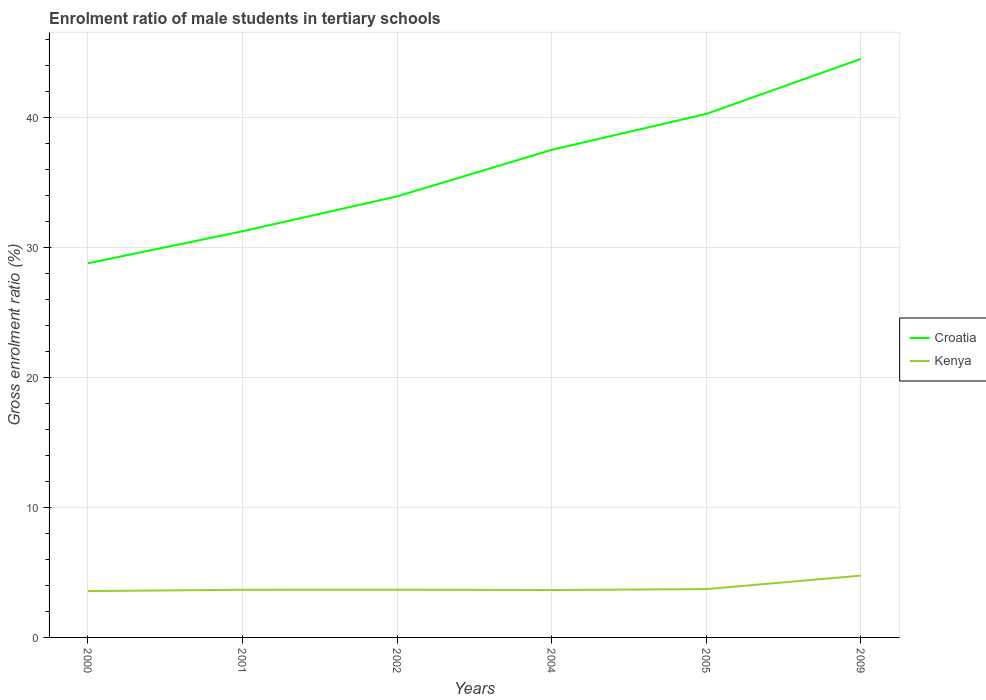Does the line corresponding to Croatia intersect with the line corresponding to Kenya?
Ensure brevity in your answer.  No. Is the number of lines equal to the number of legend labels?
Your response must be concise. Yes. Across all years, what is the maximum enrolment ratio of male students in tertiary schools in Kenya?
Provide a short and direct response. 3.56. In which year was the enrolment ratio of male students in tertiary schools in Kenya maximum?
Make the answer very short. 2000. What is the total enrolment ratio of male students in tertiary schools in Kenya in the graph?
Provide a short and direct response. -0.01. What is the difference between the highest and the second highest enrolment ratio of male students in tertiary schools in Kenya?
Ensure brevity in your answer.  1.19. What is the difference between the highest and the lowest enrolment ratio of male students in tertiary schools in Croatia?
Your answer should be very brief. 3. How many lines are there?
Offer a terse response. 2. How many years are there in the graph?
Keep it short and to the point. 6. Does the graph contain any zero values?
Provide a short and direct response. No. How are the legend labels stacked?
Make the answer very short. Vertical. What is the title of the graph?
Provide a short and direct response. Enrolment ratio of male students in tertiary schools. What is the label or title of the X-axis?
Keep it short and to the point. Years. What is the Gross enrolment ratio (%) in Croatia in 2000?
Offer a very short reply. 28.77. What is the Gross enrolment ratio (%) of Kenya in 2000?
Offer a terse response. 3.56. What is the Gross enrolment ratio (%) in Croatia in 2001?
Your answer should be very brief. 31.23. What is the Gross enrolment ratio (%) in Kenya in 2001?
Ensure brevity in your answer.  3.66. What is the Gross enrolment ratio (%) in Croatia in 2002?
Your answer should be compact. 33.92. What is the Gross enrolment ratio (%) of Kenya in 2002?
Offer a very short reply. 3.67. What is the Gross enrolment ratio (%) in Croatia in 2004?
Your answer should be very brief. 37.49. What is the Gross enrolment ratio (%) of Kenya in 2004?
Provide a short and direct response. 3.65. What is the Gross enrolment ratio (%) of Croatia in 2005?
Your answer should be compact. 40.26. What is the Gross enrolment ratio (%) of Kenya in 2005?
Keep it short and to the point. 3.72. What is the Gross enrolment ratio (%) of Croatia in 2009?
Your answer should be very brief. 44.49. What is the Gross enrolment ratio (%) of Kenya in 2009?
Offer a terse response. 4.75. Across all years, what is the maximum Gross enrolment ratio (%) of Croatia?
Make the answer very short. 44.49. Across all years, what is the maximum Gross enrolment ratio (%) of Kenya?
Ensure brevity in your answer.  4.75. Across all years, what is the minimum Gross enrolment ratio (%) in Croatia?
Keep it short and to the point. 28.77. Across all years, what is the minimum Gross enrolment ratio (%) in Kenya?
Keep it short and to the point. 3.56. What is the total Gross enrolment ratio (%) in Croatia in the graph?
Give a very brief answer. 216.16. What is the total Gross enrolment ratio (%) of Kenya in the graph?
Make the answer very short. 23.01. What is the difference between the Gross enrolment ratio (%) in Croatia in 2000 and that in 2001?
Ensure brevity in your answer.  -2.46. What is the difference between the Gross enrolment ratio (%) of Kenya in 2000 and that in 2001?
Your answer should be compact. -0.1. What is the difference between the Gross enrolment ratio (%) in Croatia in 2000 and that in 2002?
Your answer should be very brief. -5.15. What is the difference between the Gross enrolment ratio (%) of Kenya in 2000 and that in 2002?
Make the answer very short. -0.11. What is the difference between the Gross enrolment ratio (%) in Croatia in 2000 and that in 2004?
Give a very brief answer. -8.73. What is the difference between the Gross enrolment ratio (%) in Kenya in 2000 and that in 2004?
Your answer should be compact. -0.08. What is the difference between the Gross enrolment ratio (%) in Croatia in 2000 and that in 2005?
Your answer should be very brief. -11.49. What is the difference between the Gross enrolment ratio (%) of Kenya in 2000 and that in 2005?
Your answer should be compact. -0.15. What is the difference between the Gross enrolment ratio (%) of Croatia in 2000 and that in 2009?
Your answer should be compact. -15.72. What is the difference between the Gross enrolment ratio (%) of Kenya in 2000 and that in 2009?
Ensure brevity in your answer.  -1.19. What is the difference between the Gross enrolment ratio (%) in Croatia in 2001 and that in 2002?
Make the answer very short. -2.69. What is the difference between the Gross enrolment ratio (%) of Kenya in 2001 and that in 2002?
Ensure brevity in your answer.  -0.01. What is the difference between the Gross enrolment ratio (%) of Croatia in 2001 and that in 2004?
Offer a very short reply. -6.26. What is the difference between the Gross enrolment ratio (%) in Kenya in 2001 and that in 2004?
Make the answer very short. 0.02. What is the difference between the Gross enrolment ratio (%) of Croatia in 2001 and that in 2005?
Provide a short and direct response. -9.03. What is the difference between the Gross enrolment ratio (%) of Kenya in 2001 and that in 2005?
Your answer should be very brief. -0.05. What is the difference between the Gross enrolment ratio (%) in Croatia in 2001 and that in 2009?
Give a very brief answer. -13.26. What is the difference between the Gross enrolment ratio (%) of Kenya in 2001 and that in 2009?
Give a very brief answer. -1.09. What is the difference between the Gross enrolment ratio (%) in Croatia in 2002 and that in 2004?
Offer a very short reply. -3.58. What is the difference between the Gross enrolment ratio (%) of Kenya in 2002 and that in 2004?
Your answer should be compact. 0.03. What is the difference between the Gross enrolment ratio (%) of Croatia in 2002 and that in 2005?
Ensure brevity in your answer.  -6.34. What is the difference between the Gross enrolment ratio (%) in Kenya in 2002 and that in 2005?
Make the answer very short. -0.04. What is the difference between the Gross enrolment ratio (%) of Croatia in 2002 and that in 2009?
Provide a short and direct response. -10.57. What is the difference between the Gross enrolment ratio (%) of Kenya in 2002 and that in 2009?
Ensure brevity in your answer.  -1.08. What is the difference between the Gross enrolment ratio (%) of Croatia in 2004 and that in 2005?
Keep it short and to the point. -2.77. What is the difference between the Gross enrolment ratio (%) of Kenya in 2004 and that in 2005?
Your answer should be compact. -0.07. What is the difference between the Gross enrolment ratio (%) of Croatia in 2004 and that in 2009?
Your answer should be compact. -7. What is the difference between the Gross enrolment ratio (%) in Kenya in 2004 and that in 2009?
Provide a short and direct response. -1.11. What is the difference between the Gross enrolment ratio (%) in Croatia in 2005 and that in 2009?
Offer a very short reply. -4.23. What is the difference between the Gross enrolment ratio (%) of Kenya in 2005 and that in 2009?
Keep it short and to the point. -1.04. What is the difference between the Gross enrolment ratio (%) of Croatia in 2000 and the Gross enrolment ratio (%) of Kenya in 2001?
Your answer should be very brief. 25.1. What is the difference between the Gross enrolment ratio (%) in Croatia in 2000 and the Gross enrolment ratio (%) in Kenya in 2002?
Ensure brevity in your answer.  25.1. What is the difference between the Gross enrolment ratio (%) in Croatia in 2000 and the Gross enrolment ratio (%) in Kenya in 2004?
Keep it short and to the point. 25.12. What is the difference between the Gross enrolment ratio (%) of Croatia in 2000 and the Gross enrolment ratio (%) of Kenya in 2005?
Offer a terse response. 25.05. What is the difference between the Gross enrolment ratio (%) of Croatia in 2000 and the Gross enrolment ratio (%) of Kenya in 2009?
Offer a very short reply. 24.02. What is the difference between the Gross enrolment ratio (%) of Croatia in 2001 and the Gross enrolment ratio (%) of Kenya in 2002?
Keep it short and to the point. 27.56. What is the difference between the Gross enrolment ratio (%) in Croatia in 2001 and the Gross enrolment ratio (%) in Kenya in 2004?
Your answer should be very brief. 27.59. What is the difference between the Gross enrolment ratio (%) of Croatia in 2001 and the Gross enrolment ratio (%) of Kenya in 2005?
Your answer should be compact. 27.52. What is the difference between the Gross enrolment ratio (%) in Croatia in 2001 and the Gross enrolment ratio (%) in Kenya in 2009?
Your response must be concise. 26.48. What is the difference between the Gross enrolment ratio (%) of Croatia in 2002 and the Gross enrolment ratio (%) of Kenya in 2004?
Your answer should be very brief. 30.27. What is the difference between the Gross enrolment ratio (%) of Croatia in 2002 and the Gross enrolment ratio (%) of Kenya in 2005?
Ensure brevity in your answer.  30.2. What is the difference between the Gross enrolment ratio (%) in Croatia in 2002 and the Gross enrolment ratio (%) in Kenya in 2009?
Offer a very short reply. 29.16. What is the difference between the Gross enrolment ratio (%) of Croatia in 2004 and the Gross enrolment ratio (%) of Kenya in 2005?
Ensure brevity in your answer.  33.78. What is the difference between the Gross enrolment ratio (%) in Croatia in 2004 and the Gross enrolment ratio (%) in Kenya in 2009?
Provide a short and direct response. 32.74. What is the difference between the Gross enrolment ratio (%) of Croatia in 2005 and the Gross enrolment ratio (%) of Kenya in 2009?
Offer a terse response. 35.51. What is the average Gross enrolment ratio (%) of Croatia per year?
Make the answer very short. 36.03. What is the average Gross enrolment ratio (%) of Kenya per year?
Keep it short and to the point. 3.84. In the year 2000, what is the difference between the Gross enrolment ratio (%) of Croatia and Gross enrolment ratio (%) of Kenya?
Offer a terse response. 25.21. In the year 2001, what is the difference between the Gross enrolment ratio (%) in Croatia and Gross enrolment ratio (%) in Kenya?
Your response must be concise. 27.57. In the year 2002, what is the difference between the Gross enrolment ratio (%) of Croatia and Gross enrolment ratio (%) of Kenya?
Make the answer very short. 30.25. In the year 2004, what is the difference between the Gross enrolment ratio (%) of Croatia and Gross enrolment ratio (%) of Kenya?
Make the answer very short. 33.85. In the year 2005, what is the difference between the Gross enrolment ratio (%) in Croatia and Gross enrolment ratio (%) in Kenya?
Make the answer very short. 36.54. In the year 2009, what is the difference between the Gross enrolment ratio (%) of Croatia and Gross enrolment ratio (%) of Kenya?
Give a very brief answer. 39.74. What is the ratio of the Gross enrolment ratio (%) of Croatia in 2000 to that in 2001?
Offer a terse response. 0.92. What is the ratio of the Gross enrolment ratio (%) of Kenya in 2000 to that in 2001?
Offer a terse response. 0.97. What is the ratio of the Gross enrolment ratio (%) in Croatia in 2000 to that in 2002?
Give a very brief answer. 0.85. What is the ratio of the Gross enrolment ratio (%) of Kenya in 2000 to that in 2002?
Provide a short and direct response. 0.97. What is the ratio of the Gross enrolment ratio (%) of Croatia in 2000 to that in 2004?
Give a very brief answer. 0.77. What is the ratio of the Gross enrolment ratio (%) in Kenya in 2000 to that in 2004?
Keep it short and to the point. 0.98. What is the ratio of the Gross enrolment ratio (%) of Croatia in 2000 to that in 2005?
Your answer should be compact. 0.71. What is the ratio of the Gross enrolment ratio (%) in Kenya in 2000 to that in 2005?
Make the answer very short. 0.96. What is the ratio of the Gross enrolment ratio (%) of Croatia in 2000 to that in 2009?
Provide a succinct answer. 0.65. What is the ratio of the Gross enrolment ratio (%) of Kenya in 2000 to that in 2009?
Give a very brief answer. 0.75. What is the ratio of the Gross enrolment ratio (%) of Croatia in 2001 to that in 2002?
Keep it short and to the point. 0.92. What is the ratio of the Gross enrolment ratio (%) in Kenya in 2001 to that in 2002?
Keep it short and to the point. 1. What is the ratio of the Gross enrolment ratio (%) in Croatia in 2001 to that in 2004?
Keep it short and to the point. 0.83. What is the ratio of the Gross enrolment ratio (%) of Kenya in 2001 to that in 2004?
Make the answer very short. 1.01. What is the ratio of the Gross enrolment ratio (%) in Croatia in 2001 to that in 2005?
Provide a short and direct response. 0.78. What is the ratio of the Gross enrolment ratio (%) of Kenya in 2001 to that in 2005?
Ensure brevity in your answer.  0.99. What is the ratio of the Gross enrolment ratio (%) in Croatia in 2001 to that in 2009?
Give a very brief answer. 0.7. What is the ratio of the Gross enrolment ratio (%) of Kenya in 2001 to that in 2009?
Your response must be concise. 0.77. What is the ratio of the Gross enrolment ratio (%) of Croatia in 2002 to that in 2004?
Provide a short and direct response. 0.9. What is the ratio of the Gross enrolment ratio (%) in Kenya in 2002 to that in 2004?
Your response must be concise. 1.01. What is the ratio of the Gross enrolment ratio (%) in Croatia in 2002 to that in 2005?
Provide a short and direct response. 0.84. What is the ratio of the Gross enrolment ratio (%) of Croatia in 2002 to that in 2009?
Provide a succinct answer. 0.76. What is the ratio of the Gross enrolment ratio (%) in Kenya in 2002 to that in 2009?
Make the answer very short. 0.77. What is the ratio of the Gross enrolment ratio (%) of Croatia in 2004 to that in 2005?
Give a very brief answer. 0.93. What is the ratio of the Gross enrolment ratio (%) in Kenya in 2004 to that in 2005?
Provide a short and direct response. 0.98. What is the ratio of the Gross enrolment ratio (%) of Croatia in 2004 to that in 2009?
Your answer should be compact. 0.84. What is the ratio of the Gross enrolment ratio (%) of Kenya in 2004 to that in 2009?
Ensure brevity in your answer.  0.77. What is the ratio of the Gross enrolment ratio (%) of Croatia in 2005 to that in 2009?
Offer a terse response. 0.9. What is the ratio of the Gross enrolment ratio (%) in Kenya in 2005 to that in 2009?
Your response must be concise. 0.78. What is the difference between the highest and the second highest Gross enrolment ratio (%) of Croatia?
Provide a succinct answer. 4.23. What is the difference between the highest and the second highest Gross enrolment ratio (%) in Kenya?
Ensure brevity in your answer.  1.04. What is the difference between the highest and the lowest Gross enrolment ratio (%) of Croatia?
Your answer should be compact. 15.72. What is the difference between the highest and the lowest Gross enrolment ratio (%) in Kenya?
Offer a very short reply. 1.19. 